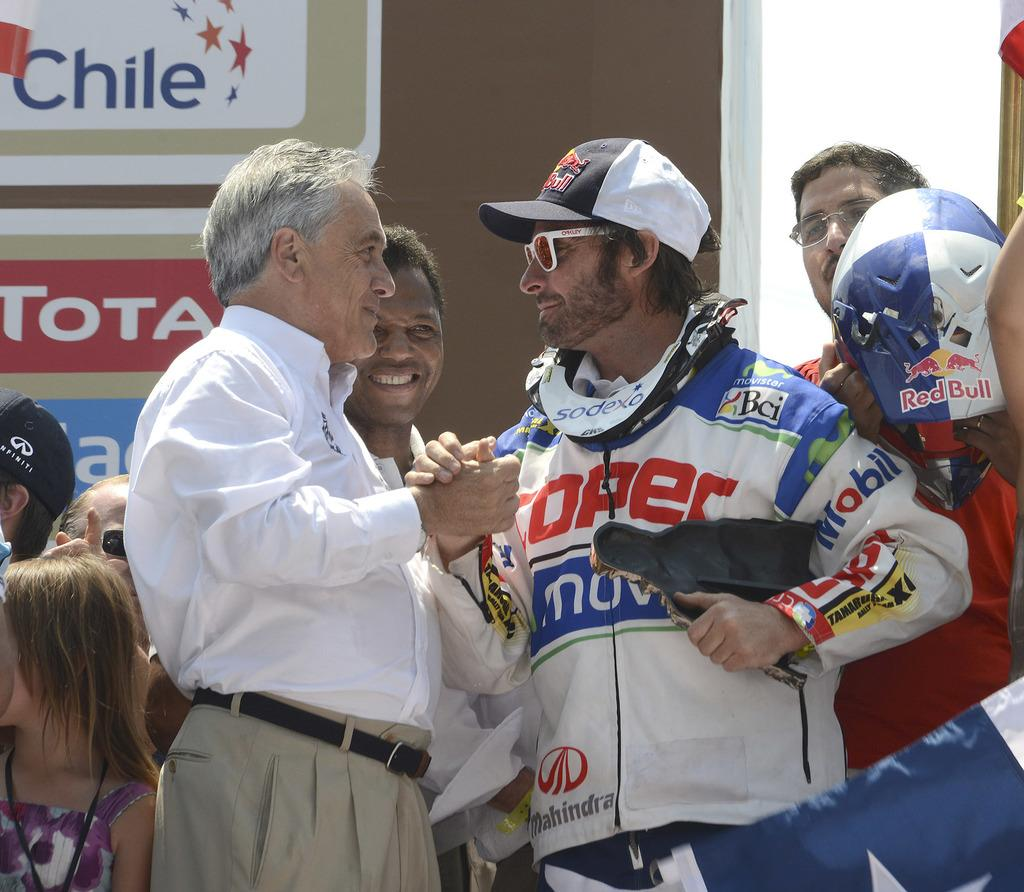<image>
Summarize the visual content of the image. a sign that had the word Chile next to a driver 